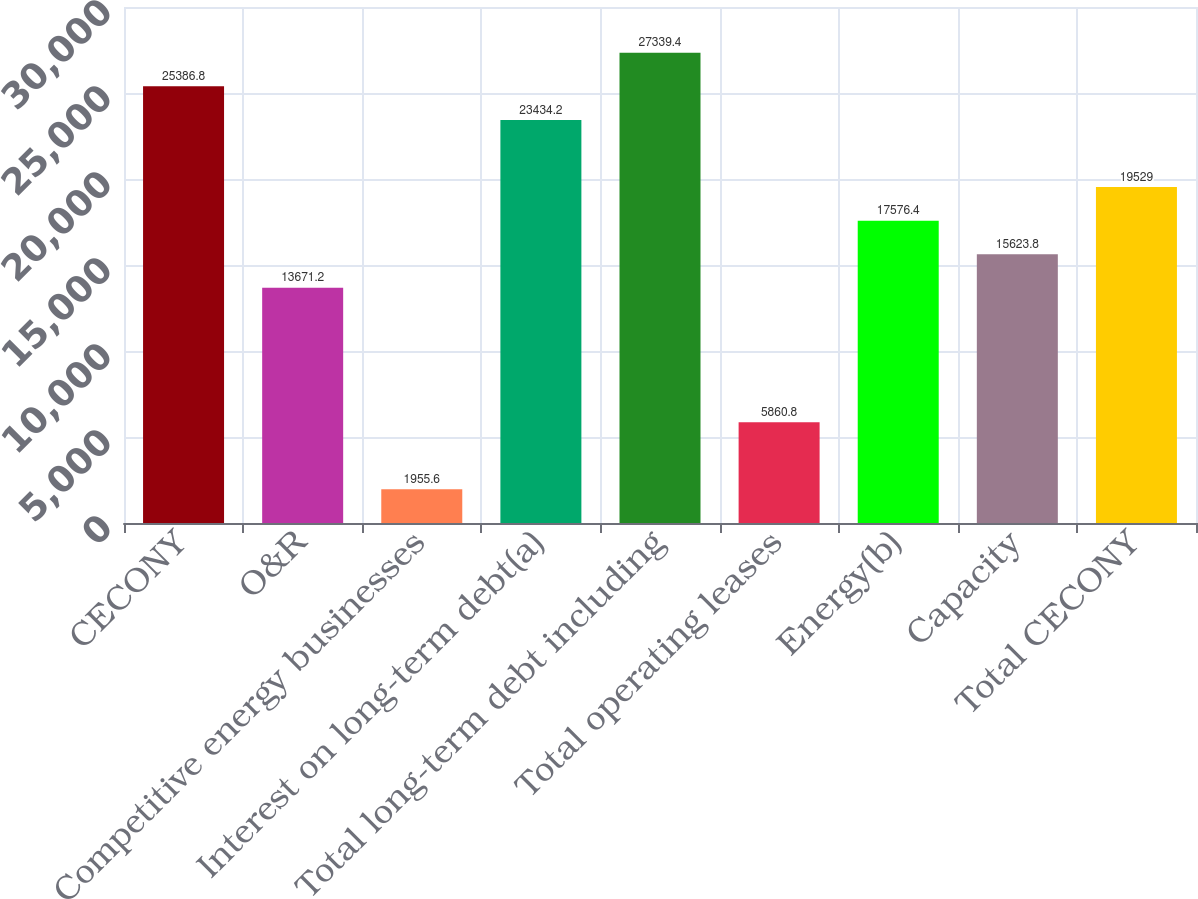Convert chart. <chart><loc_0><loc_0><loc_500><loc_500><bar_chart><fcel>CECONY<fcel>O&R<fcel>Competitive energy businesses<fcel>Interest on long-term debt(a)<fcel>Total long-term debt including<fcel>Total operating leases<fcel>Energy(b)<fcel>Capacity<fcel>Total CECONY<nl><fcel>25386.8<fcel>13671.2<fcel>1955.6<fcel>23434.2<fcel>27339.4<fcel>5860.8<fcel>17576.4<fcel>15623.8<fcel>19529<nl></chart> 